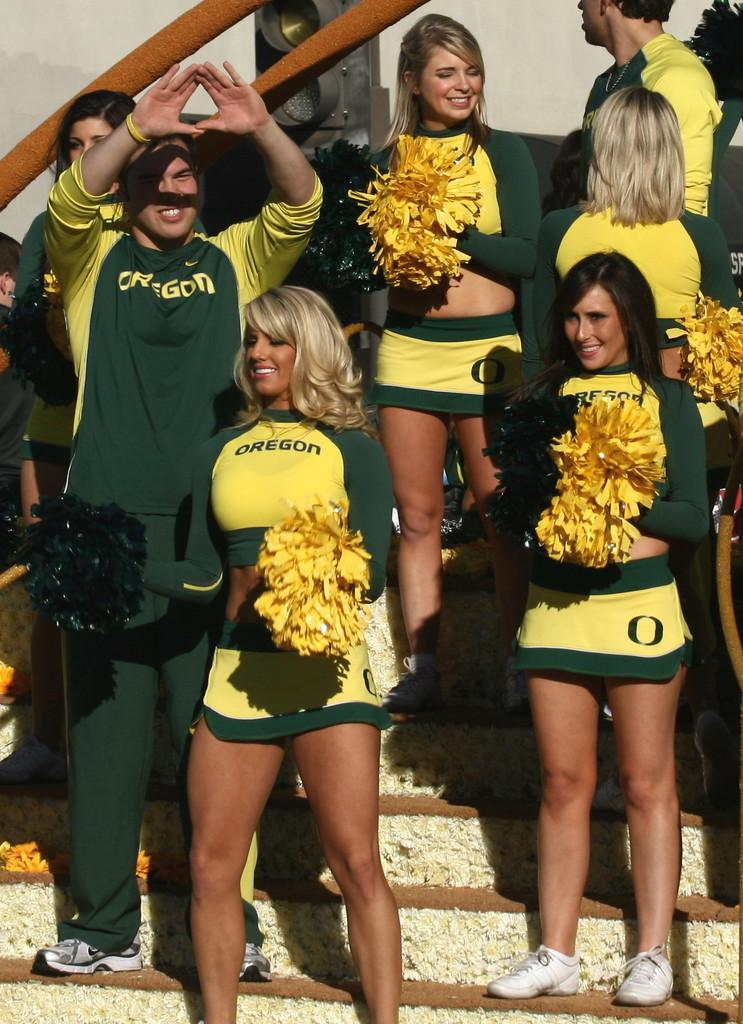<image>
Provide a brief description of the given image. Oregon logo on a cheerleading uniform with an O logo on the skirt. 